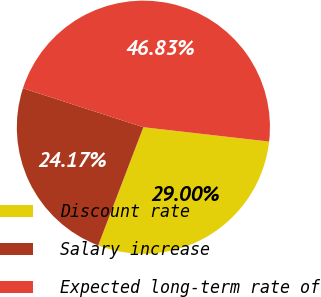Convert chart to OTSL. <chart><loc_0><loc_0><loc_500><loc_500><pie_chart><fcel>Discount rate<fcel>Salary increase<fcel>Expected long-term rate of<nl><fcel>29.0%<fcel>24.17%<fcel>46.83%<nl></chart> 